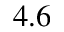Convert formula to latex. <formula><loc_0><loc_0><loc_500><loc_500>4 . 6</formula> 